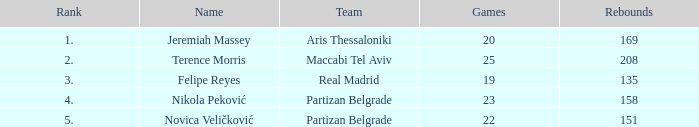How many games has nikola peković of partizan belgrade played with a rank higher than 4? None. 